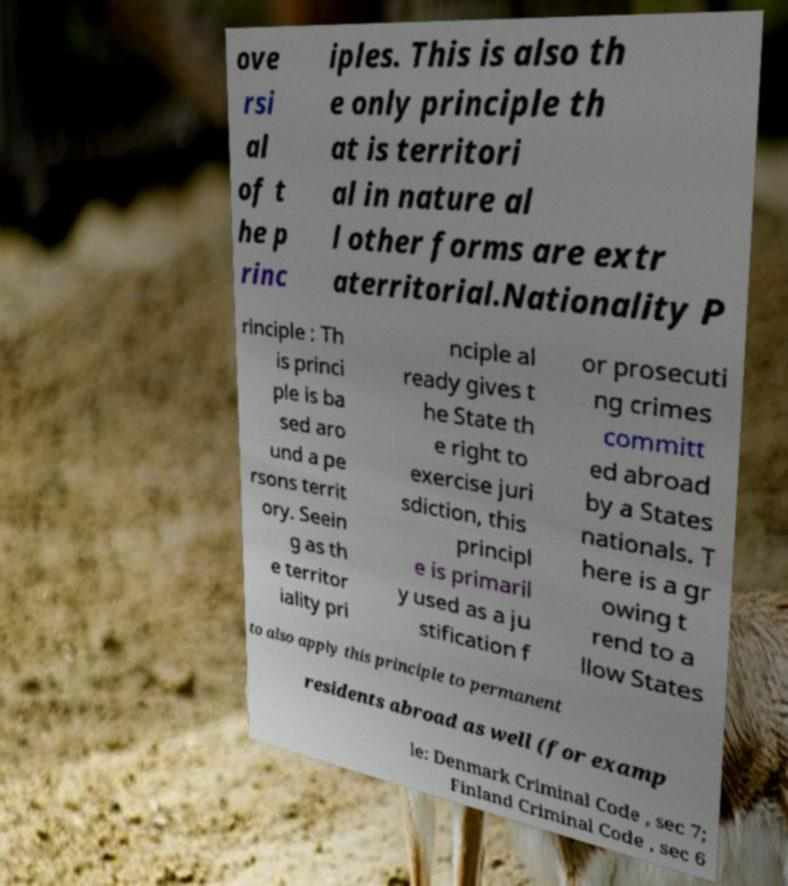Please identify and transcribe the text found in this image. ove rsi al of t he p rinc iples. This is also th e only principle th at is territori al in nature al l other forms are extr aterritorial.Nationality P rinciple : Th is princi ple is ba sed aro und a pe rsons territ ory. Seein g as th e territor iality pri nciple al ready gives t he State th e right to exercise juri sdiction, this principl e is primaril y used as a ju stification f or prosecuti ng crimes committ ed abroad by a States nationals. T here is a gr owing t rend to a llow States to also apply this principle to permanent residents abroad as well (for examp le: Denmark Criminal Code , sec 7; Finland Criminal Code , sec 6 